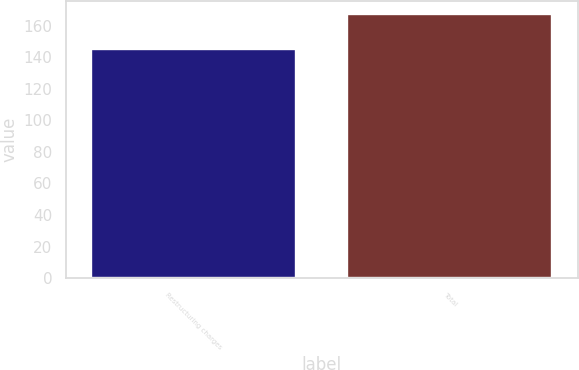Convert chart. <chart><loc_0><loc_0><loc_500><loc_500><bar_chart><fcel>Restructuring charges<fcel>Total<nl><fcel>144.9<fcel>167.1<nl></chart> 